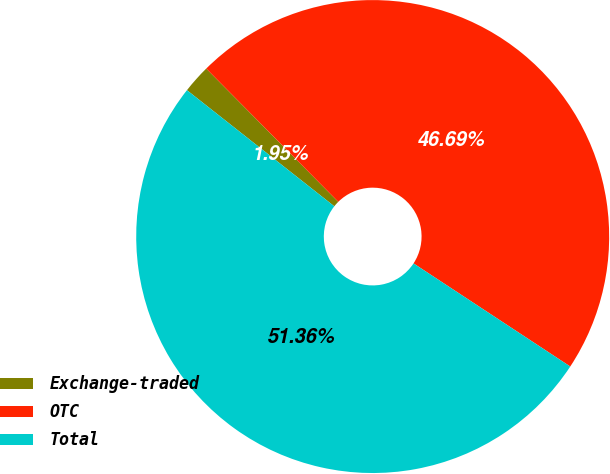Convert chart to OTSL. <chart><loc_0><loc_0><loc_500><loc_500><pie_chart><fcel>Exchange-traded<fcel>OTC<fcel>Total<nl><fcel>1.95%<fcel>46.69%<fcel>51.36%<nl></chart> 